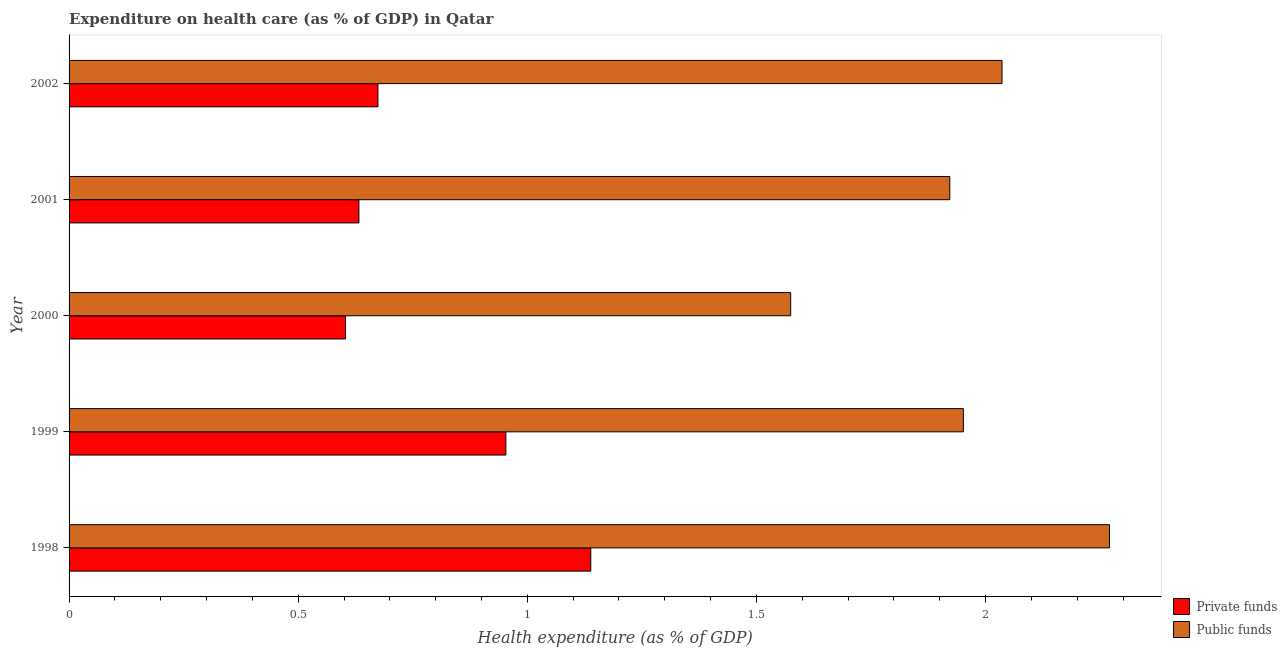How many groups of bars are there?
Keep it short and to the point. 5. What is the amount of private funds spent in healthcare in 1999?
Provide a succinct answer. 0.95. Across all years, what is the maximum amount of public funds spent in healthcare?
Provide a short and direct response. 2.27. Across all years, what is the minimum amount of public funds spent in healthcare?
Your response must be concise. 1.57. In which year was the amount of private funds spent in healthcare minimum?
Your answer should be very brief. 2000. What is the total amount of private funds spent in healthcare in the graph?
Your answer should be very brief. 4. What is the difference between the amount of private funds spent in healthcare in 1998 and that in 2000?
Your answer should be compact. 0.54. What is the difference between the amount of public funds spent in healthcare in 1998 and the amount of private funds spent in healthcare in 2000?
Offer a very short reply. 1.67. What is the ratio of the amount of public funds spent in healthcare in 2000 to that in 2001?
Your response must be concise. 0.82. Is the amount of private funds spent in healthcare in 1998 less than that in 2001?
Your answer should be very brief. No. Is the difference between the amount of private funds spent in healthcare in 1999 and 2001 greater than the difference between the amount of public funds spent in healthcare in 1999 and 2001?
Provide a succinct answer. Yes. What is the difference between the highest and the second highest amount of public funds spent in healthcare?
Keep it short and to the point. 0.23. What is the difference between the highest and the lowest amount of private funds spent in healthcare?
Ensure brevity in your answer.  0.54. Is the sum of the amount of public funds spent in healthcare in 1998 and 2001 greater than the maximum amount of private funds spent in healthcare across all years?
Your answer should be compact. Yes. What does the 1st bar from the top in 1999 represents?
Your answer should be compact. Public funds. What does the 2nd bar from the bottom in 1998 represents?
Ensure brevity in your answer.  Public funds. Does the graph contain grids?
Provide a short and direct response. No. Where does the legend appear in the graph?
Offer a very short reply. Bottom right. How many legend labels are there?
Provide a succinct answer. 2. How are the legend labels stacked?
Provide a short and direct response. Vertical. What is the title of the graph?
Give a very brief answer. Expenditure on health care (as % of GDP) in Qatar. What is the label or title of the X-axis?
Provide a succinct answer. Health expenditure (as % of GDP). What is the label or title of the Y-axis?
Provide a succinct answer. Year. What is the Health expenditure (as % of GDP) in Private funds in 1998?
Ensure brevity in your answer.  1.14. What is the Health expenditure (as % of GDP) in Public funds in 1998?
Provide a short and direct response. 2.27. What is the Health expenditure (as % of GDP) of Private funds in 1999?
Give a very brief answer. 0.95. What is the Health expenditure (as % of GDP) in Public funds in 1999?
Ensure brevity in your answer.  1.95. What is the Health expenditure (as % of GDP) of Private funds in 2000?
Your answer should be very brief. 0.6. What is the Health expenditure (as % of GDP) in Public funds in 2000?
Your answer should be compact. 1.57. What is the Health expenditure (as % of GDP) in Private funds in 2001?
Ensure brevity in your answer.  0.63. What is the Health expenditure (as % of GDP) of Public funds in 2001?
Ensure brevity in your answer.  1.92. What is the Health expenditure (as % of GDP) in Private funds in 2002?
Provide a short and direct response. 0.67. What is the Health expenditure (as % of GDP) in Public funds in 2002?
Your answer should be very brief. 2.04. Across all years, what is the maximum Health expenditure (as % of GDP) in Private funds?
Make the answer very short. 1.14. Across all years, what is the maximum Health expenditure (as % of GDP) of Public funds?
Make the answer very short. 2.27. Across all years, what is the minimum Health expenditure (as % of GDP) in Private funds?
Your answer should be compact. 0.6. Across all years, what is the minimum Health expenditure (as % of GDP) of Public funds?
Your answer should be very brief. 1.57. What is the total Health expenditure (as % of GDP) of Private funds in the graph?
Offer a terse response. 4. What is the total Health expenditure (as % of GDP) in Public funds in the graph?
Keep it short and to the point. 9.75. What is the difference between the Health expenditure (as % of GDP) of Private funds in 1998 and that in 1999?
Your response must be concise. 0.19. What is the difference between the Health expenditure (as % of GDP) in Public funds in 1998 and that in 1999?
Offer a very short reply. 0.32. What is the difference between the Health expenditure (as % of GDP) in Private funds in 1998 and that in 2000?
Offer a terse response. 0.54. What is the difference between the Health expenditure (as % of GDP) of Public funds in 1998 and that in 2000?
Make the answer very short. 0.7. What is the difference between the Health expenditure (as % of GDP) in Private funds in 1998 and that in 2001?
Give a very brief answer. 0.51. What is the difference between the Health expenditure (as % of GDP) of Public funds in 1998 and that in 2001?
Provide a short and direct response. 0.35. What is the difference between the Health expenditure (as % of GDP) in Private funds in 1998 and that in 2002?
Provide a succinct answer. 0.46. What is the difference between the Health expenditure (as % of GDP) of Public funds in 1998 and that in 2002?
Your answer should be very brief. 0.23. What is the difference between the Health expenditure (as % of GDP) of Private funds in 1999 and that in 2000?
Provide a short and direct response. 0.35. What is the difference between the Health expenditure (as % of GDP) of Public funds in 1999 and that in 2000?
Give a very brief answer. 0.38. What is the difference between the Health expenditure (as % of GDP) in Private funds in 1999 and that in 2001?
Make the answer very short. 0.32. What is the difference between the Health expenditure (as % of GDP) in Public funds in 1999 and that in 2001?
Your answer should be very brief. 0.03. What is the difference between the Health expenditure (as % of GDP) of Private funds in 1999 and that in 2002?
Your answer should be compact. 0.28. What is the difference between the Health expenditure (as % of GDP) of Public funds in 1999 and that in 2002?
Your answer should be very brief. -0.08. What is the difference between the Health expenditure (as % of GDP) in Private funds in 2000 and that in 2001?
Provide a succinct answer. -0.03. What is the difference between the Health expenditure (as % of GDP) in Public funds in 2000 and that in 2001?
Ensure brevity in your answer.  -0.35. What is the difference between the Health expenditure (as % of GDP) in Private funds in 2000 and that in 2002?
Offer a terse response. -0.07. What is the difference between the Health expenditure (as % of GDP) of Public funds in 2000 and that in 2002?
Offer a terse response. -0.46. What is the difference between the Health expenditure (as % of GDP) of Private funds in 2001 and that in 2002?
Keep it short and to the point. -0.04. What is the difference between the Health expenditure (as % of GDP) in Public funds in 2001 and that in 2002?
Offer a terse response. -0.11. What is the difference between the Health expenditure (as % of GDP) of Private funds in 1998 and the Health expenditure (as % of GDP) of Public funds in 1999?
Offer a very short reply. -0.81. What is the difference between the Health expenditure (as % of GDP) of Private funds in 1998 and the Health expenditure (as % of GDP) of Public funds in 2000?
Provide a short and direct response. -0.44. What is the difference between the Health expenditure (as % of GDP) in Private funds in 1998 and the Health expenditure (as % of GDP) in Public funds in 2001?
Ensure brevity in your answer.  -0.78. What is the difference between the Health expenditure (as % of GDP) of Private funds in 1998 and the Health expenditure (as % of GDP) of Public funds in 2002?
Your answer should be very brief. -0.9. What is the difference between the Health expenditure (as % of GDP) of Private funds in 1999 and the Health expenditure (as % of GDP) of Public funds in 2000?
Offer a very short reply. -0.62. What is the difference between the Health expenditure (as % of GDP) in Private funds in 1999 and the Health expenditure (as % of GDP) in Public funds in 2001?
Keep it short and to the point. -0.97. What is the difference between the Health expenditure (as % of GDP) in Private funds in 1999 and the Health expenditure (as % of GDP) in Public funds in 2002?
Make the answer very short. -1.08. What is the difference between the Health expenditure (as % of GDP) in Private funds in 2000 and the Health expenditure (as % of GDP) in Public funds in 2001?
Provide a succinct answer. -1.32. What is the difference between the Health expenditure (as % of GDP) of Private funds in 2000 and the Health expenditure (as % of GDP) of Public funds in 2002?
Your response must be concise. -1.43. What is the difference between the Health expenditure (as % of GDP) of Private funds in 2001 and the Health expenditure (as % of GDP) of Public funds in 2002?
Offer a terse response. -1.4. What is the average Health expenditure (as % of GDP) in Private funds per year?
Make the answer very short. 0.8. What is the average Health expenditure (as % of GDP) in Public funds per year?
Make the answer very short. 1.95. In the year 1998, what is the difference between the Health expenditure (as % of GDP) of Private funds and Health expenditure (as % of GDP) of Public funds?
Your answer should be compact. -1.13. In the year 1999, what is the difference between the Health expenditure (as % of GDP) in Private funds and Health expenditure (as % of GDP) in Public funds?
Make the answer very short. -1. In the year 2000, what is the difference between the Health expenditure (as % of GDP) in Private funds and Health expenditure (as % of GDP) in Public funds?
Your answer should be very brief. -0.97. In the year 2001, what is the difference between the Health expenditure (as % of GDP) of Private funds and Health expenditure (as % of GDP) of Public funds?
Keep it short and to the point. -1.29. In the year 2002, what is the difference between the Health expenditure (as % of GDP) of Private funds and Health expenditure (as % of GDP) of Public funds?
Give a very brief answer. -1.36. What is the ratio of the Health expenditure (as % of GDP) in Private funds in 1998 to that in 1999?
Ensure brevity in your answer.  1.19. What is the ratio of the Health expenditure (as % of GDP) of Public funds in 1998 to that in 1999?
Your answer should be very brief. 1.16. What is the ratio of the Health expenditure (as % of GDP) in Private funds in 1998 to that in 2000?
Your answer should be compact. 1.89. What is the ratio of the Health expenditure (as % of GDP) of Public funds in 1998 to that in 2000?
Make the answer very short. 1.44. What is the ratio of the Health expenditure (as % of GDP) of Public funds in 1998 to that in 2001?
Provide a short and direct response. 1.18. What is the ratio of the Health expenditure (as % of GDP) of Private funds in 1998 to that in 2002?
Offer a terse response. 1.69. What is the ratio of the Health expenditure (as % of GDP) in Public funds in 1998 to that in 2002?
Provide a short and direct response. 1.12. What is the ratio of the Health expenditure (as % of GDP) of Private funds in 1999 to that in 2000?
Ensure brevity in your answer.  1.58. What is the ratio of the Health expenditure (as % of GDP) in Public funds in 1999 to that in 2000?
Offer a terse response. 1.24. What is the ratio of the Health expenditure (as % of GDP) in Private funds in 1999 to that in 2001?
Your answer should be compact. 1.51. What is the ratio of the Health expenditure (as % of GDP) in Public funds in 1999 to that in 2001?
Make the answer very short. 1.02. What is the ratio of the Health expenditure (as % of GDP) of Private funds in 1999 to that in 2002?
Provide a short and direct response. 1.41. What is the ratio of the Health expenditure (as % of GDP) in Public funds in 1999 to that in 2002?
Make the answer very short. 0.96. What is the ratio of the Health expenditure (as % of GDP) in Private funds in 2000 to that in 2001?
Offer a very short reply. 0.95. What is the ratio of the Health expenditure (as % of GDP) of Public funds in 2000 to that in 2001?
Provide a short and direct response. 0.82. What is the ratio of the Health expenditure (as % of GDP) of Private funds in 2000 to that in 2002?
Keep it short and to the point. 0.9. What is the ratio of the Health expenditure (as % of GDP) in Public funds in 2000 to that in 2002?
Give a very brief answer. 0.77. What is the ratio of the Health expenditure (as % of GDP) of Private funds in 2001 to that in 2002?
Offer a terse response. 0.94. What is the ratio of the Health expenditure (as % of GDP) of Public funds in 2001 to that in 2002?
Offer a terse response. 0.94. What is the difference between the highest and the second highest Health expenditure (as % of GDP) in Private funds?
Your answer should be compact. 0.19. What is the difference between the highest and the second highest Health expenditure (as % of GDP) of Public funds?
Make the answer very short. 0.23. What is the difference between the highest and the lowest Health expenditure (as % of GDP) of Private funds?
Ensure brevity in your answer.  0.54. What is the difference between the highest and the lowest Health expenditure (as % of GDP) of Public funds?
Provide a succinct answer. 0.7. 